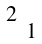Convert formula to latex. <formula><loc_0><loc_0><loc_500><loc_500>\begin{smallmatrix} 2 \\ & 1 \end{smallmatrix}</formula> 